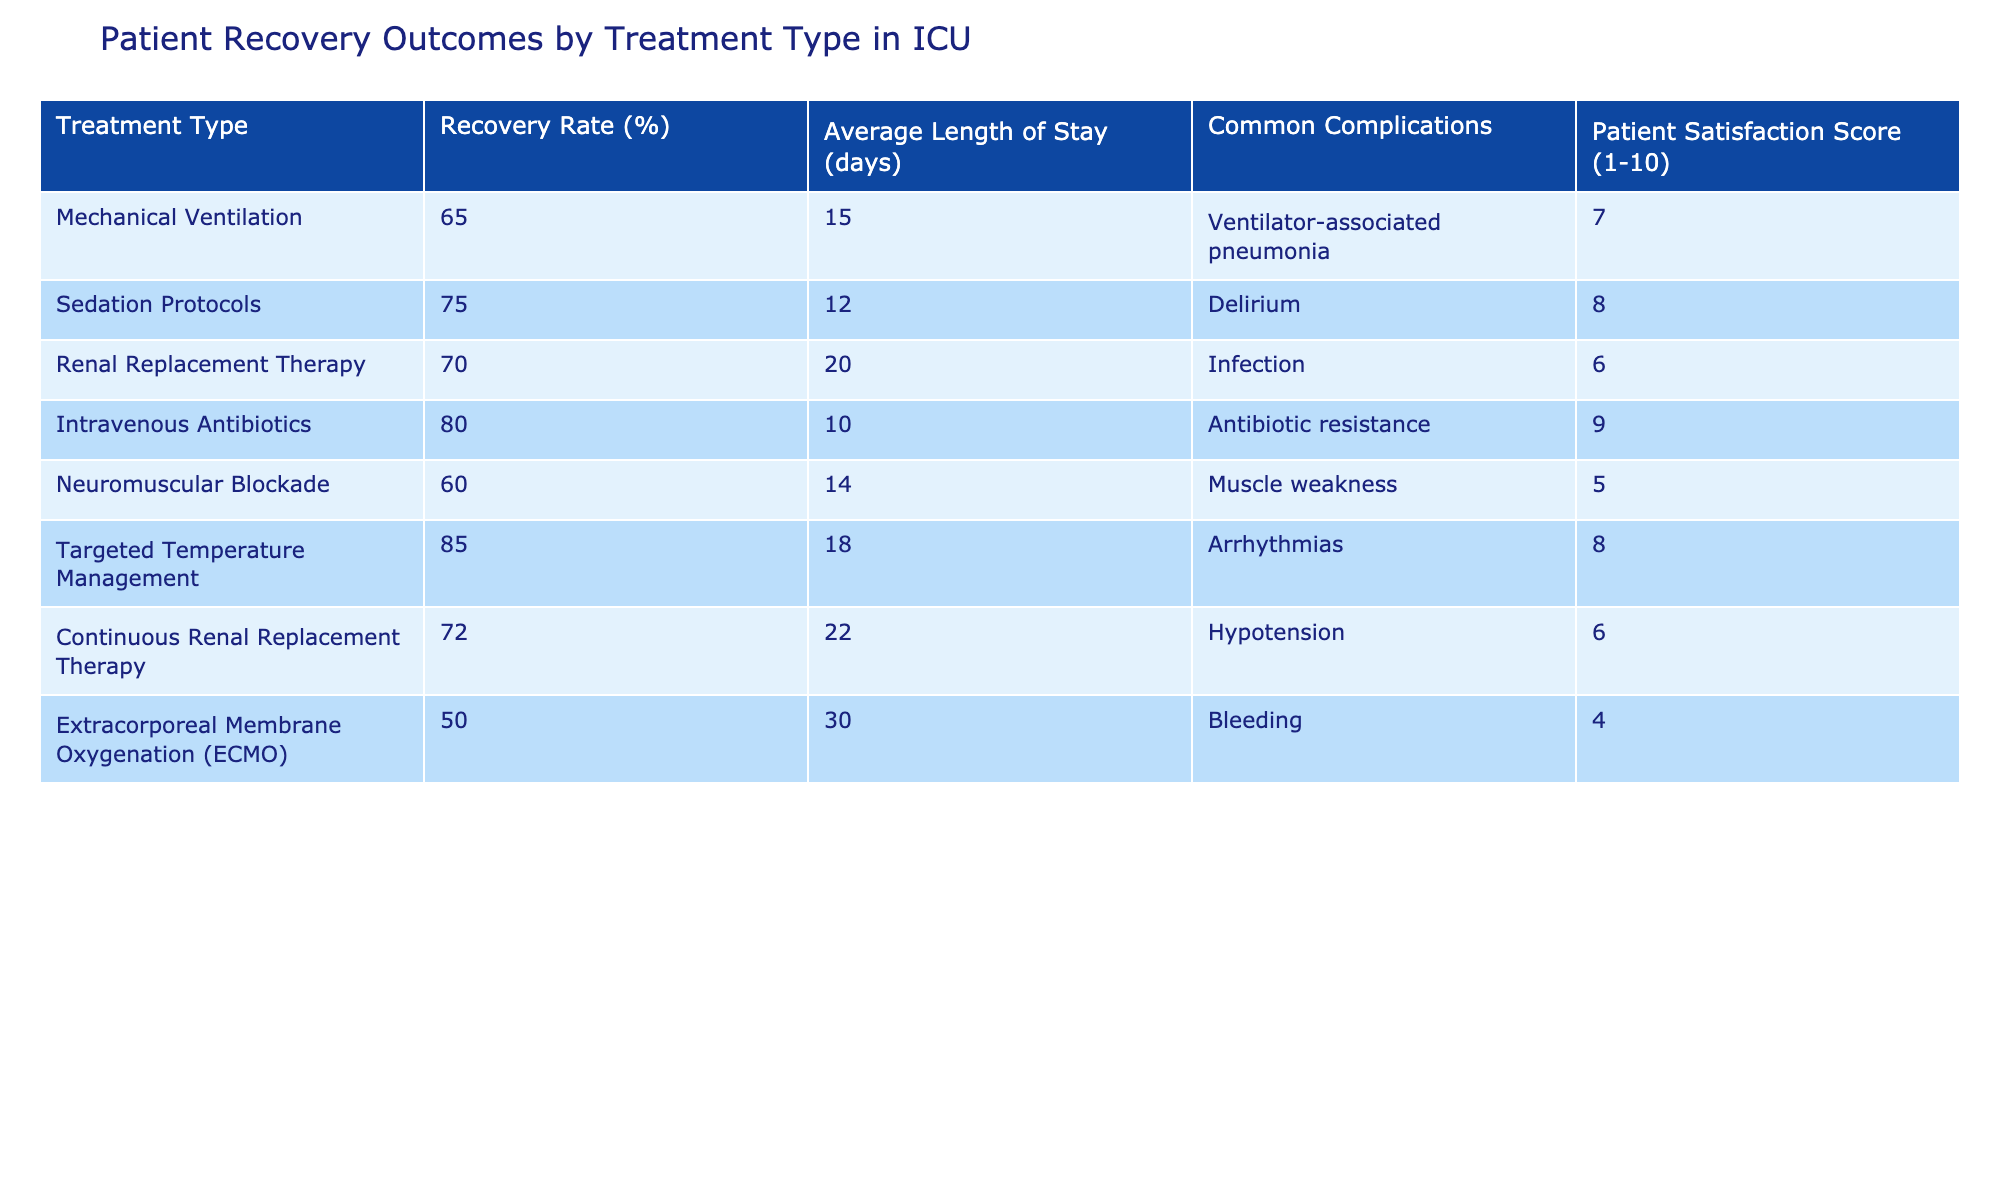What is the recovery rate for Intravenous Antibiotics? The recovery rate for Intravenous Antibiotics is listed in the table under the Recovery Rate (%) column, which shows 80%.
Answer: 80% Which treatment type has the highest patient satisfaction score? By examining the Patient Satisfaction Score column, the highest score is 9 for Intravenous Antibiotics.
Answer: Intravenous Antibiotics What is the average length of stay for patients treated with Continuous Renal Replacement Therapy? The Average Length of Stay (days) column indicates that Continuous Renal Replacement Therapy has an average length of stay of 22 days.
Answer: 22 days Is the recovery rate for Neuromuscular Blockade higher than that for Mechanical Ventilation? The recovery rate for Neuromuscular Blockade is 60%, while for Mechanical Ventilation, it is 65%. Since 60% is not greater than 65%, this statement is false.
Answer: No What is the difference in average length of stay between the treatment types with the highest and lowest recovery rates? The highest recovery rate is 85% for Targeted Temperature Management, with an average length of stay of 18 days. The lowest recovery rate is 50% for ECMO, with an average length of stay of 30 days. The difference in average length of stay is 30 - 18 = 12 days.
Answer: 12 days Do more complications typically occur with Renal Replacement Therapy than with Sedation Protocols? The Common Complications column shows that the complication for Renal Replacement Therapy is Infection, while for Sedation Protocols, it is Delirium. Both have complications, but without numeric data on frequency, we cannot definitively say there are more complications with one than the other.
Answer: Cannot determine Which treatment type has a recovery rate lower than 70%? Looking at the Recovery Rate (%) column, the treatments with lower recovery rates than 70% are Mechanical Ventilation (65%) and Neuromuscular Blockade (60%), as both are below 70%.
Answer: Mechanical Ventilation, Neuromuscular Blockade What is the average patient satisfaction score for treatment types associated with complications of infection? The treatment types that have "Infection" as a common complication are Renal Replacement Therapy (score 6) and Continuous Renal Replacement Therapy (score 6). To find the average: (6 + 6) / 2 = 6.
Answer: 6 How many treatment types have recovery rates above 70%? By reviewing the Recovery Rate (%) column, the treatment types with recovery rates above 70% are Sedation Protocols (75%), Intravenous Antibiotics (80%), and Targeted Temperature Management (85%). Thus, there are three treatment types.
Answer: 3 